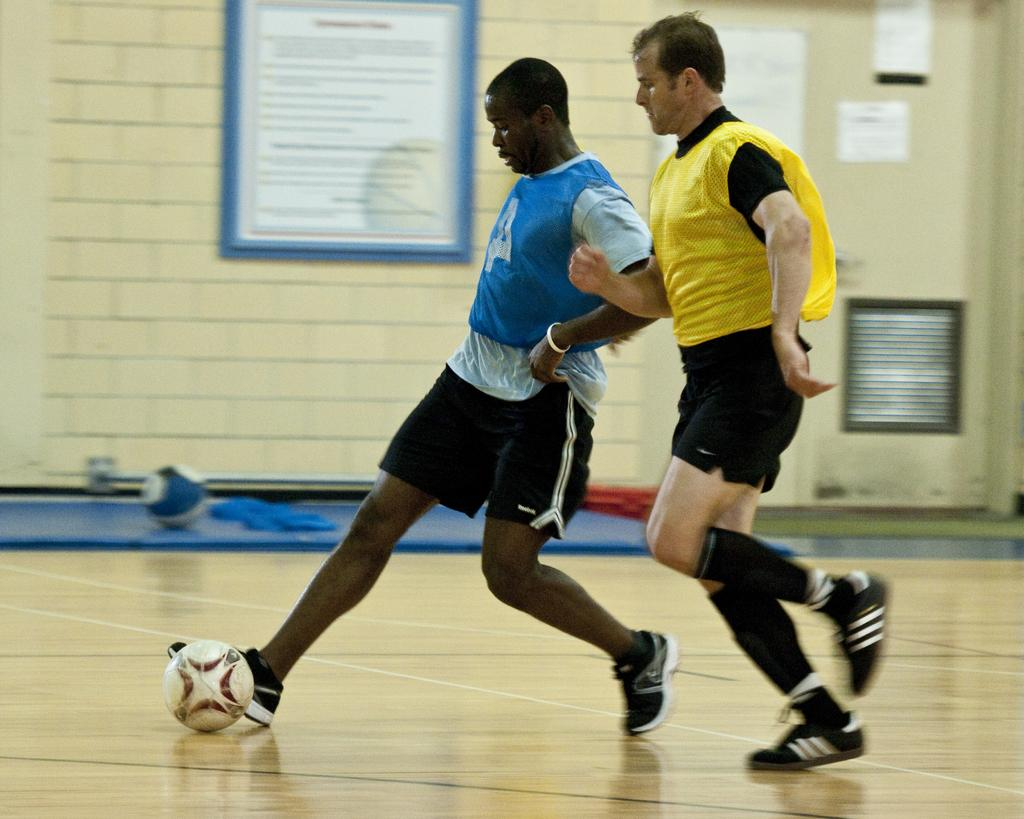How many people are in the image? There are two persons in the image. What are the two persons doing in the image? The two persons are playing with a ball. What can be seen in the background of the image? There is a wall and frames in the background of the image. Where is the sink located in the image? There is no sink present in the image. Are the two persons in the image fighting or playing peacefully? The two persons are playing peacefully with a ball, as there is no indication of a fight in the image. 